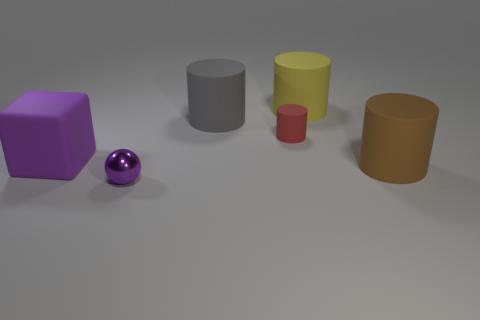There is another object that is the same color as the shiny thing; what is its size?
Give a very brief answer. Large. Do the large thing in front of the big block and the small red rubber object have the same shape?
Your response must be concise. Yes. There is a large rubber cylinder that is to the left of the big yellow rubber cylinder; what color is it?
Make the answer very short. Gray. What shape is the yellow thing that is the same material as the big purple block?
Your answer should be very brief. Cylinder. Is there any other thing of the same color as the sphere?
Make the answer very short. Yes. Are there more cubes behind the small shiny sphere than large gray matte objects that are in front of the large brown cylinder?
Provide a succinct answer. Yes. What number of matte things have the same size as the purple sphere?
Make the answer very short. 1. Is the number of purple matte cubes to the right of the yellow thing less than the number of tiny purple metal spheres that are behind the purple matte block?
Offer a very short reply. No. Is there a large object that has the same shape as the small red matte object?
Offer a terse response. Yes. Does the brown thing have the same shape as the small purple thing?
Make the answer very short. No. 